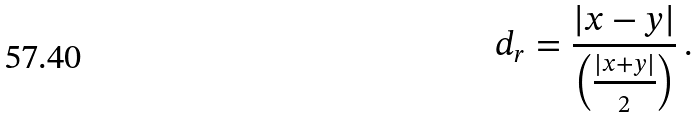<formula> <loc_0><loc_0><loc_500><loc_500>d _ { r } = { \frac { | x - y | } { \left ( { \frac { | x + y | } { 2 } } \right ) } } \, .</formula> 